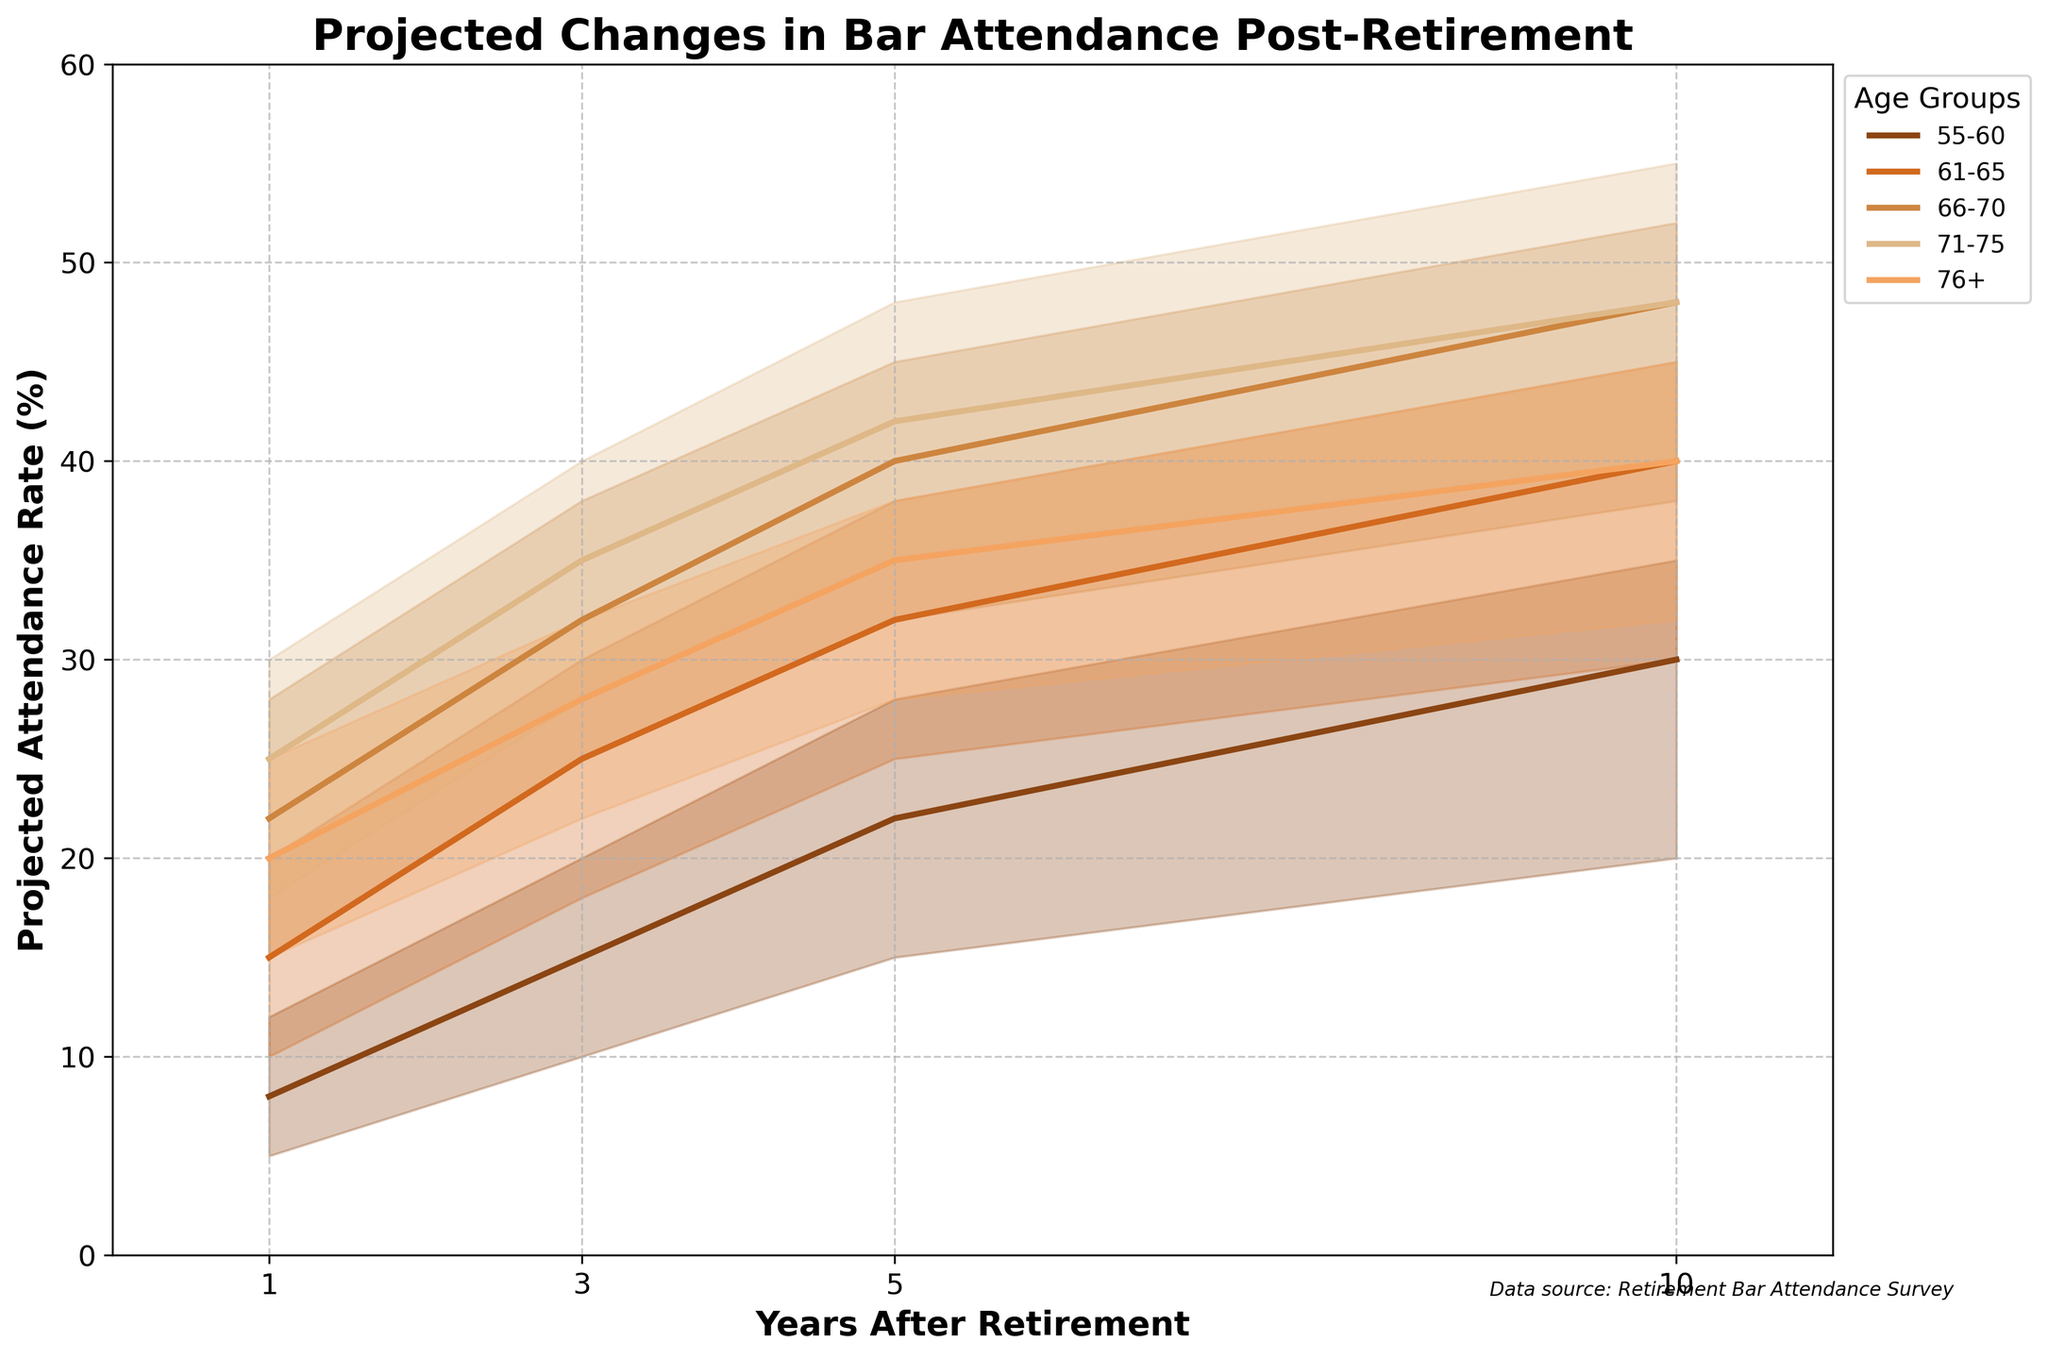What is the title of the chart? The title of the chart is found at the top and provides an overall understanding of what the chart is about.
Answer: Projected Changes in Bar Attendance Post-Retirement What does the x-axis represent? The x-axis label indicates the variable represented along the horizontal dimension of the chart.
Answer: Years After Retirement Which age group has the highest projected attendance rate after 1 year? To find the highest projected attendance rate, look at the data points on the left (1 year) for each age group and identify the highest value.
Answer: 71-75 How does the bar attendance rate change for the 66-70 age group with low income from 1 year to 10 years post-retirement? For the 66-70 age group, trace the values on the chart for low income from 1 year to 10 years: 15%, 25%, 32%, 38%.
Answer: It increases from 15% to 38% Which income level within the 61-65 age group shows the greatest increase in bar attendance over 10 years? Compare the increase from 1 year to 10 years for low, medium, and high incomes within the 61-65 age group. The values are 10% to 30%, 15% to 40%, and 20% to 45%, respectively.
Answer: High What is the difference in projected bar attendance rates after 5 years between the 55-60 age group with a high income and the 76+ age group with a low income? Subtract the 76+ age group's low-income rate (28%) from the 55-60 age group's high-income rate (28%).
Answer: 0% Which age group has the most narrow range of attendance rates in the first year? The range for each group in the first year is the difference between high and low incomes. The 55-60 (12%-5%), 61-65 (20%-10%), 66-70 (28%-15%), 71-75 (30%-18%), and 76+ (25%-15%). The smallest difference is for the 55-60 age group (7%).
Answer: 55-60 For the 55-60 age group, what is the average projected attendance rate across all income levels after 5 years of retirement? Add the projected rates for low (15%), medium (22%), and high (28%) and divide by 3.
Answer: (15+22+28)/3 = 21.67% How does projected bar attendance change over 10 years for low-income individuals above 76? Look at the data points representing the low-income for 76+ age group from 1 year to 10 years: 15%, 22%, 28%, 32%.
Answer: It increases from 15% to 32% 